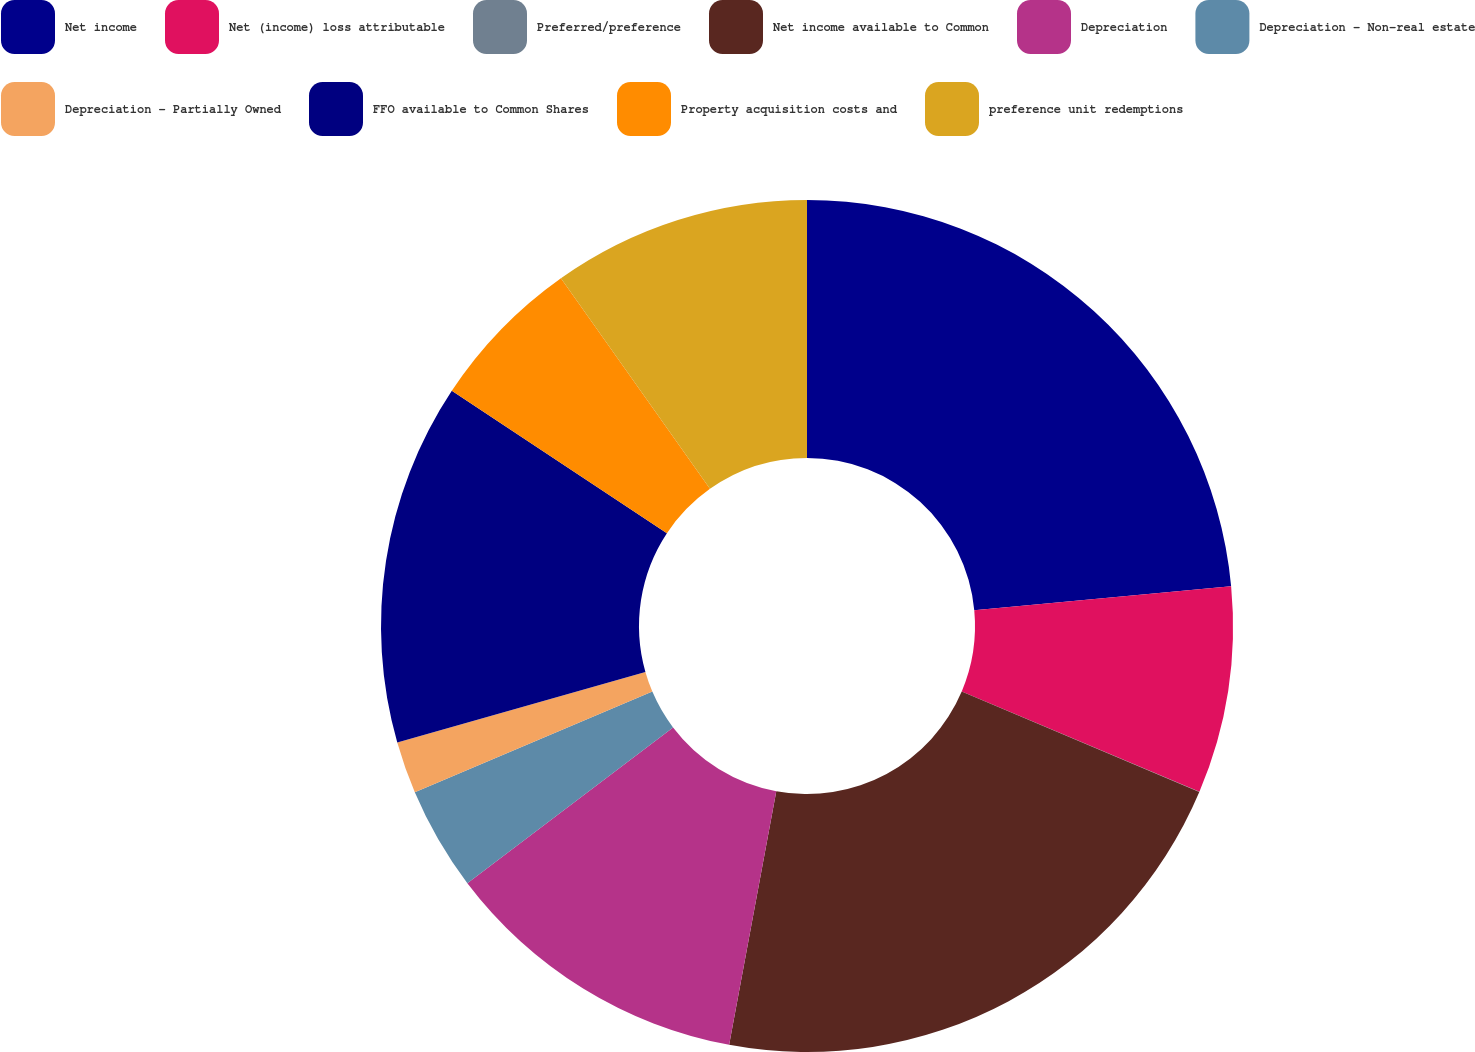Convert chart to OTSL. <chart><loc_0><loc_0><loc_500><loc_500><pie_chart><fcel>Net income<fcel>Net (income) loss attributable<fcel>Preferred/preference<fcel>Net income available to Common<fcel>Depreciation<fcel>Depreciation - Non-real estate<fcel>Depreciation - Partially Owned<fcel>FFO available to Common Shares<fcel>Property acquisition costs and<fcel>preference unit redemptions<nl><fcel>23.51%<fcel>7.85%<fcel>0.01%<fcel>21.55%<fcel>11.76%<fcel>3.93%<fcel>1.97%<fcel>13.72%<fcel>5.89%<fcel>9.8%<nl></chart> 